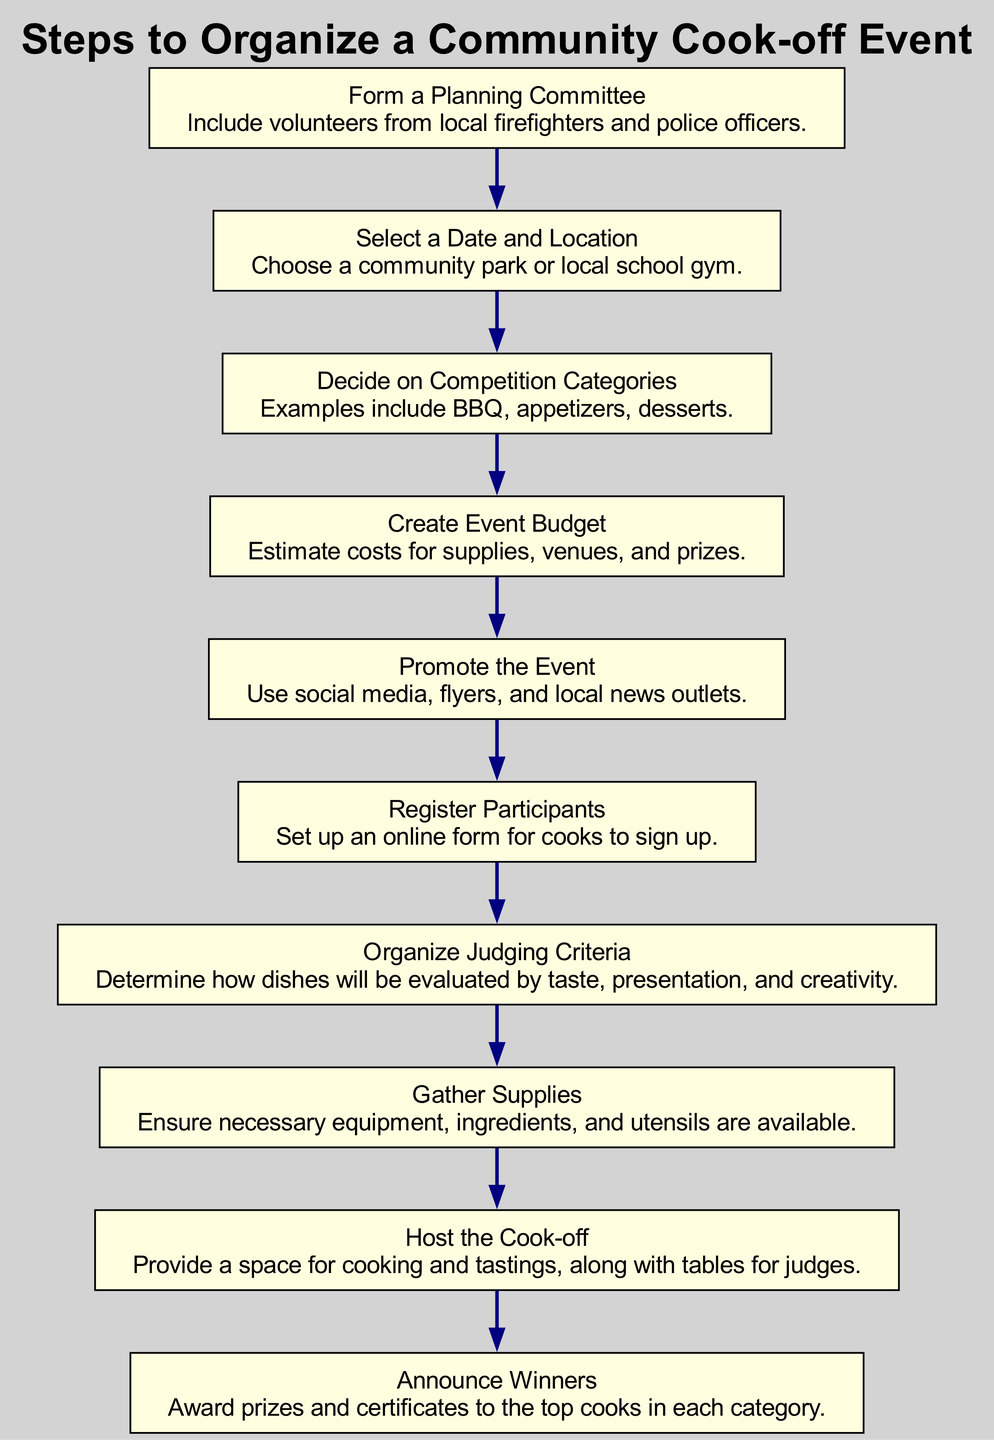What is the first step in the diagram? The first step listed in the diagram is "Form a Planning Committee." This is the starting point and can be found at the top of the flow chart.
Answer: Form a Planning Committee How many competition categories are mentioned? The diagram explicitly states examples of competition categories as BBQ, appetizers, and desserts, totaling three categories.
Answer: Three What comes after 'Select a Date and Location'? Following 'Select a Date and Location', the next step is 'Decide on Competition Categories.' This shows the flow from one step to the next.
Answer: Decide on Competition Categories Which step involves setting up an online form? The step that involves setting up an online form is 'Register Participants.' This is where cooks can sign up for the event.
Answer: Register Participants What is the final step in the process? The final step of the flow chart is 'Announce Winners,' indicating that this is the last action taken after all other steps have been completed.
Answer: Announce Winners How does the 'Create Event Budget' relate to 'Gather Supplies'? The 'Create Event Budget' precedes 'Gather Supplies.' After budgeting, supplies can be gathered, indicating a sequential relationship between these two steps.
Answer: Creational relationship What is the role of the planning committee in this process? The role of the planning committee is to organize and plan the event, ensuring that volunteers are involved from local firefighters and police officers.
Answer: Organize the event Where is the cook-off suggested to take place? The cook-off is suggested to take place in a community park or a local school gym as indicated in the 'Select a Date and Location' step.
Answer: Community park or local school gym 